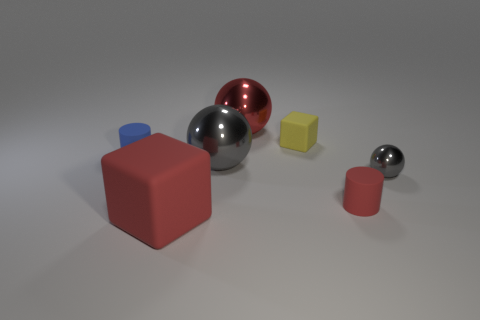Add 1 big red metallic things. How many objects exist? 8 Subtract all cylinders. How many objects are left? 5 Subtract 1 red spheres. How many objects are left? 6 Subtract all tiny red objects. Subtract all red metallic balls. How many objects are left? 5 Add 4 big metal spheres. How many big metal spheres are left? 6 Add 4 large green shiny cylinders. How many large green shiny cylinders exist? 4 